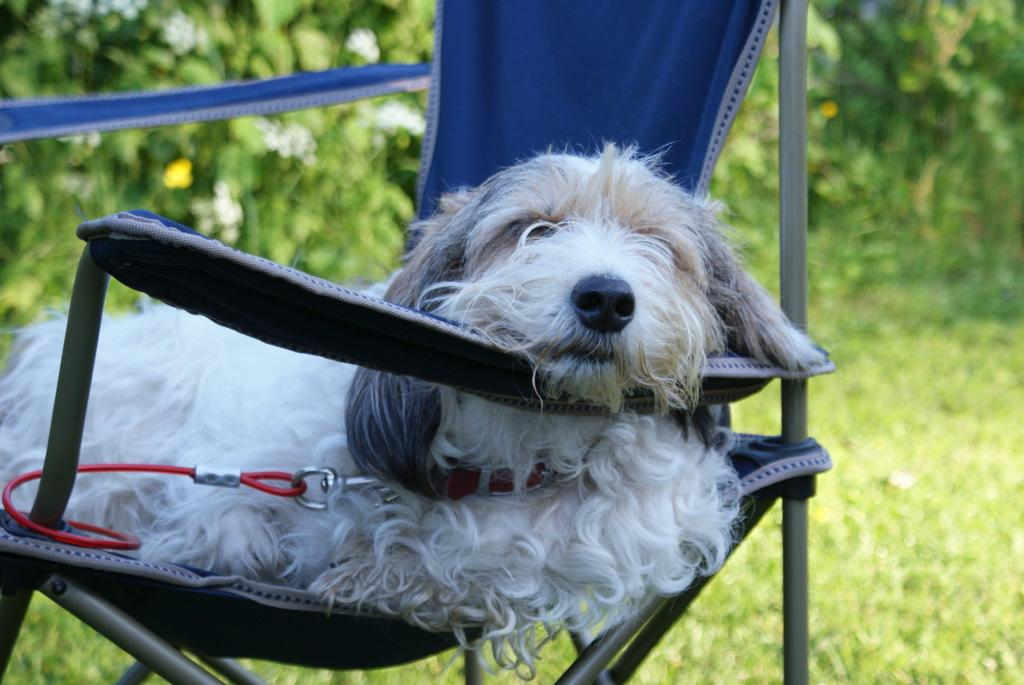What animal can be seen in the picture? There is a dog in the picture. What is the dog doing in the image? The dog is sitting on a chair. What type of surface is under the dog's feet? There is grass on the floor. What can be seen in the background of the image? There are plants in the backdrop of the image. How is the background of the image depicted? The backdrop of the image is blurred. Who is the expert in the image? There is no expert present in the image; it features a dog sitting on a chair. What type of disease can be seen in the image? There is no disease present in the image; it features a dog sitting on a chair. 